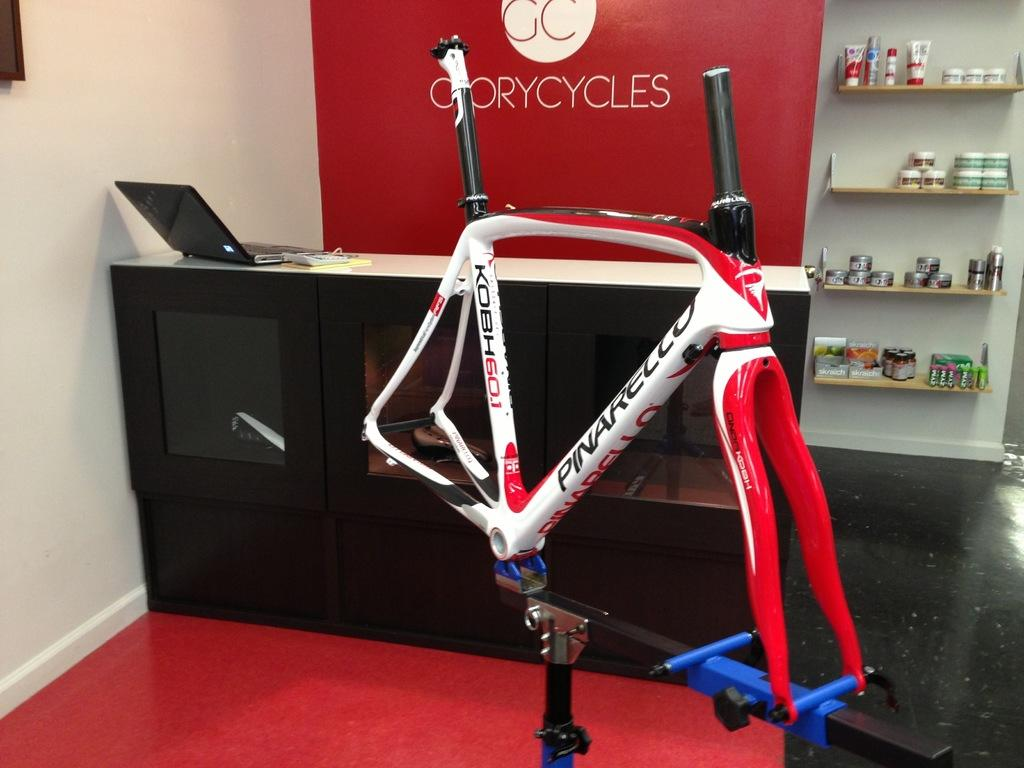Provide a one-sentence caption for the provided image. A cycling machine in the middle of the room with a sign that says Gorycycles. 